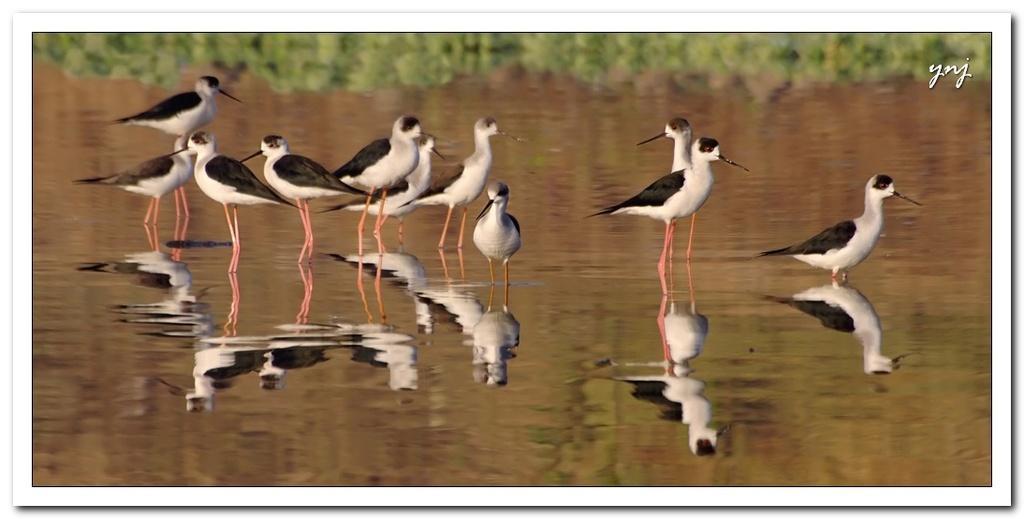Could you give a brief overview of what you see in this image? In this image there is a water surface, in that there are birds, on the top right there is text, in the background it is blurred. 